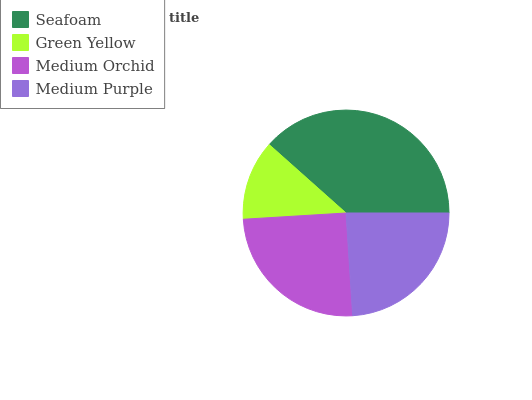Is Green Yellow the minimum?
Answer yes or no. Yes. Is Seafoam the maximum?
Answer yes or no. Yes. Is Medium Orchid the minimum?
Answer yes or no. No. Is Medium Orchid the maximum?
Answer yes or no. No. Is Medium Orchid greater than Green Yellow?
Answer yes or no. Yes. Is Green Yellow less than Medium Orchid?
Answer yes or no. Yes. Is Green Yellow greater than Medium Orchid?
Answer yes or no. No. Is Medium Orchid less than Green Yellow?
Answer yes or no. No. Is Medium Orchid the high median?
Answer yes or no. Yes. Is Medium Purple the low median?
Answer yes or no. Yes. Is Green Yellow the high median?
Answer yes or no. No. Is Medium Orchid the low median?
Answer yes or no. No. 